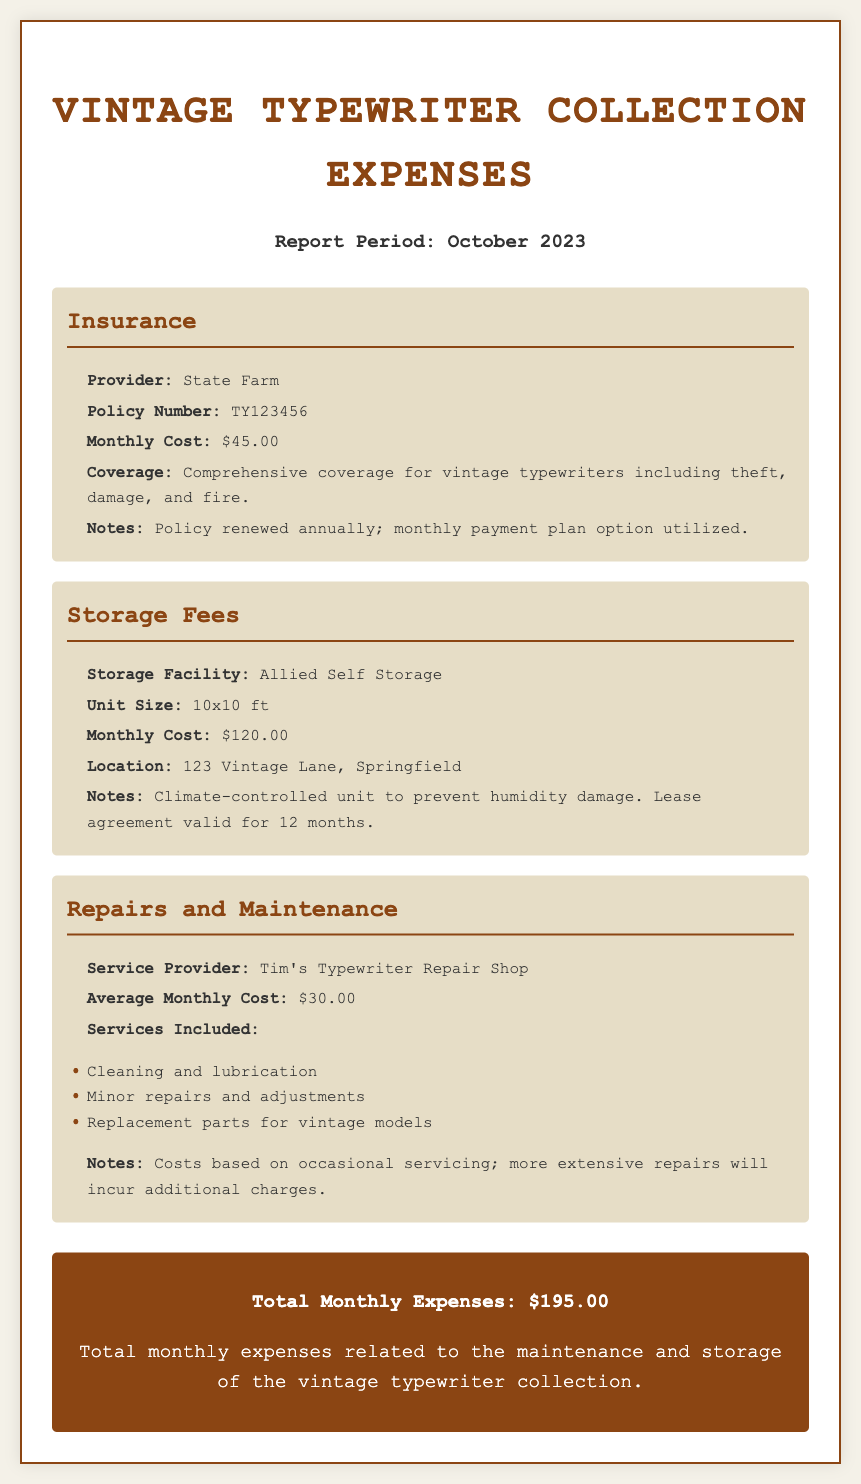What is the monthly cost of insurance? The monthly cost of insurance is explicitly stated in the document under the Insurance section.
Answer: $45.00 What is the name of the storage facility? The name of the storage facility is provided in the Storage Fees section of the document.
Answer: Allied Self Storage What is the average monthly cost for repairs? The document mentions the average monthly cost related to repairs and maintenance services.
Answer: $30.00 What is the total monthly expense for the typewriter collection? The total monthly expenses are calculated and presented at the end of the document.
Answer: $195.00 What type of coverage does the insurance provide? The document describes the kind of coverage included in the insurance policy.
Answer: Comprehensive coverage for vintage typewriters including theft, damage, and fire How large is the storage unit? The size of the storage unit is detailed in the Storage Fees section.
Answer: 10x10 ft How often is the insurance policy renewed? This information is included in the notes under the Insurance category in the document.
Answer: Annually What services are included in the repair costs? The document lists the services covered under the average monthly cost for repairs.
Answer: Cleaning and lubrication, minor repairs and adjustments, replacement parts for vintage models What is the location of the storage facility? The document specifies the address of the storage facility in the Storage Fees section.
Answer: 123 Vintage Lane, Springfield 